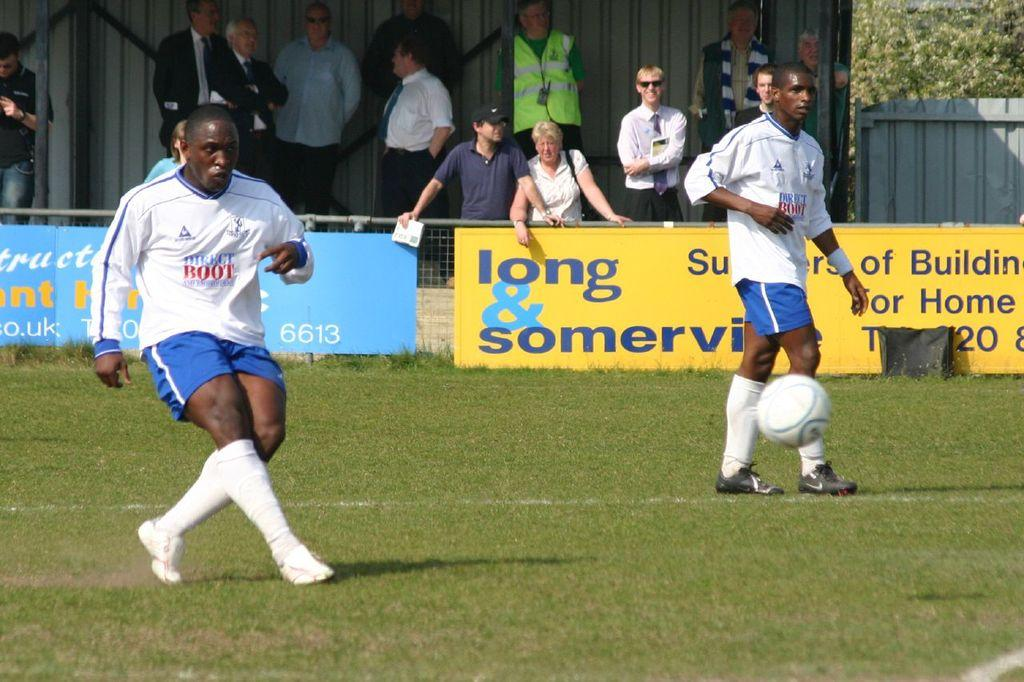<image>
Create a compact narrative representing the image presented. Two Direct Boot soccer players wearing white jerseys and blue shorts. 